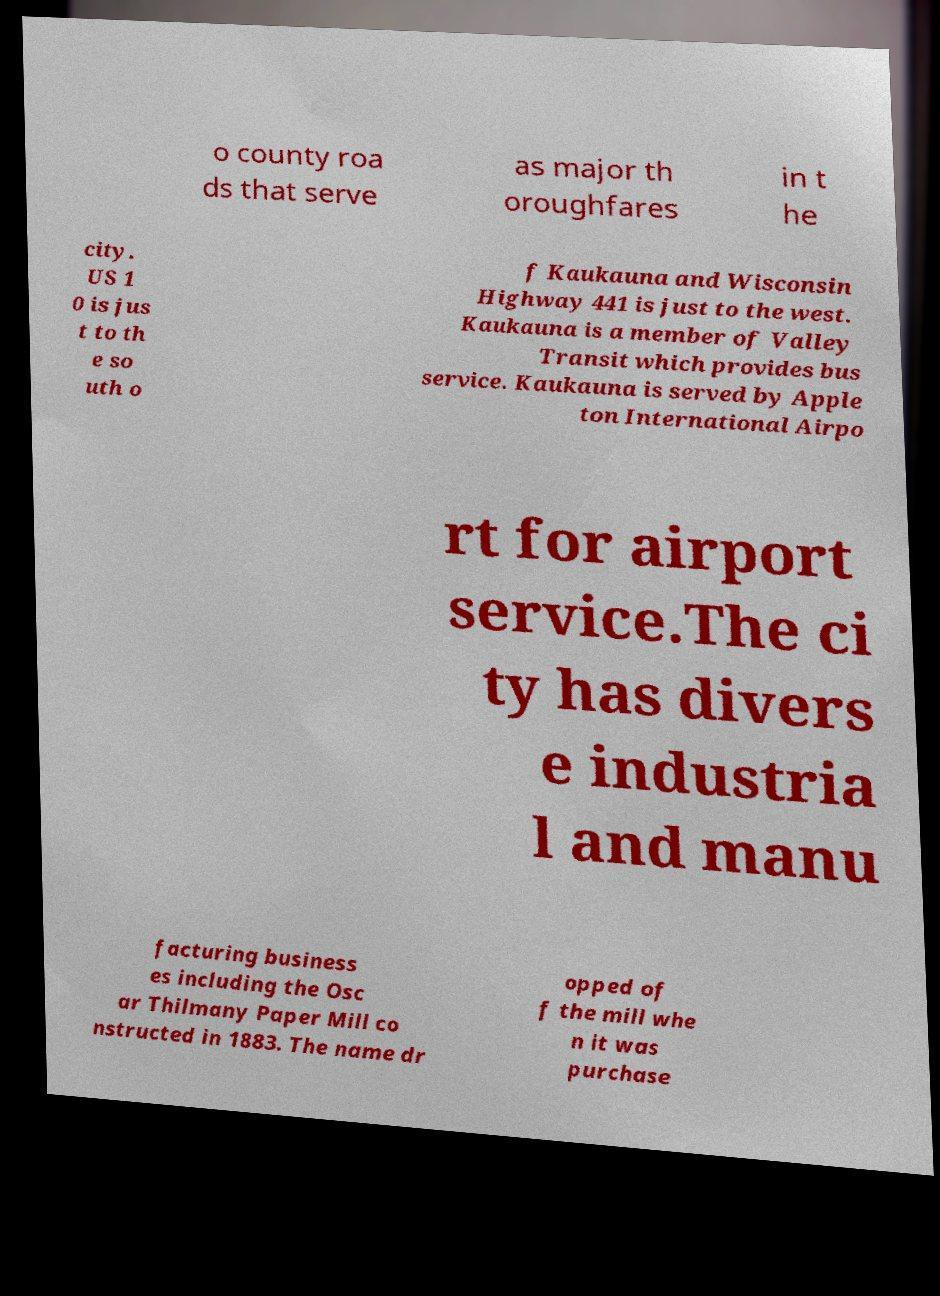Can you read and provide the text displayed in the image?This photo seems to have some interesting text. Can you extract and type it out for me? o county roa ds that serve as major th oroughfares in t he city. US 1 0 is jus t to th e so uth o f Kaukauna and Wisconsin Highway 441 is just to the west. Kaukauna is a member of Valley Transit which provides bus service. Kaukauna is served by Apple ton International Airpo rt for airport service.The ci ty has divers e industria l and manu facturing business es including the Osc ar Thilmany Paper Mill co nstructed in 1883. The name dr opped of f the mill whe n it was purchase 